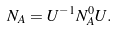Convert formula to latex. <formula><loc_0><loc_0><loc_500><loc_500>N _ { A } = U ^ { - 1 } N _ { A } ^ { 0 } U .</formula> 